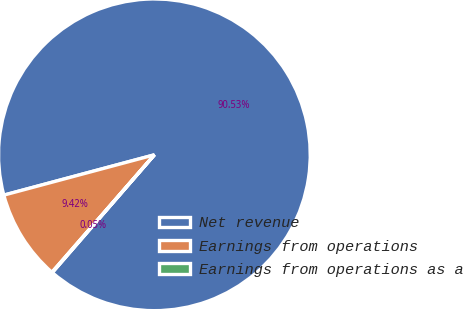Convert chart to OTSL. <chart><loc_0><loc_0><loc_500><loc_500><pie_chart><fcel>Net revenue<fcel>Earnings from operations<fcel>Earnings from operations as a<nl><fcel>90.53%<fcel>9.42%<fcel>0.05%<nl></chart> 